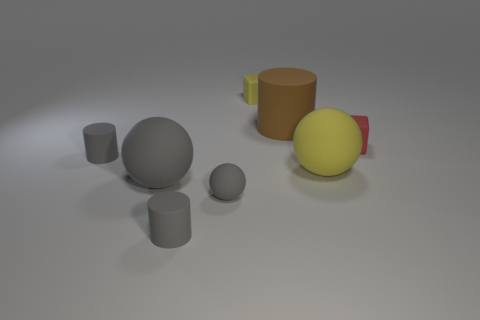Subtract all yellow balls. How many balls are left? 2 Subtract all purple balls. How many gray cylinders are left? 2 Add 2 cubes. How many objects exist? 10 Subtract 1 cylinders. How many cylinders are left? 2 Subtract all purple spheres. Subtract all purple blocks. How many spheres are left? 3 Subtract all balls. How many objects are left? 5 Add 3 small matte cylinders. How many small matte cylinders are left? 5 Add 7 big yellow spheres. How many big yellow spheres exist? 8 Subtract 0 purple cubes. How many objects are left? 8 Subtract all large purple things. Subtract all cylinders. How many objects are left? 5 